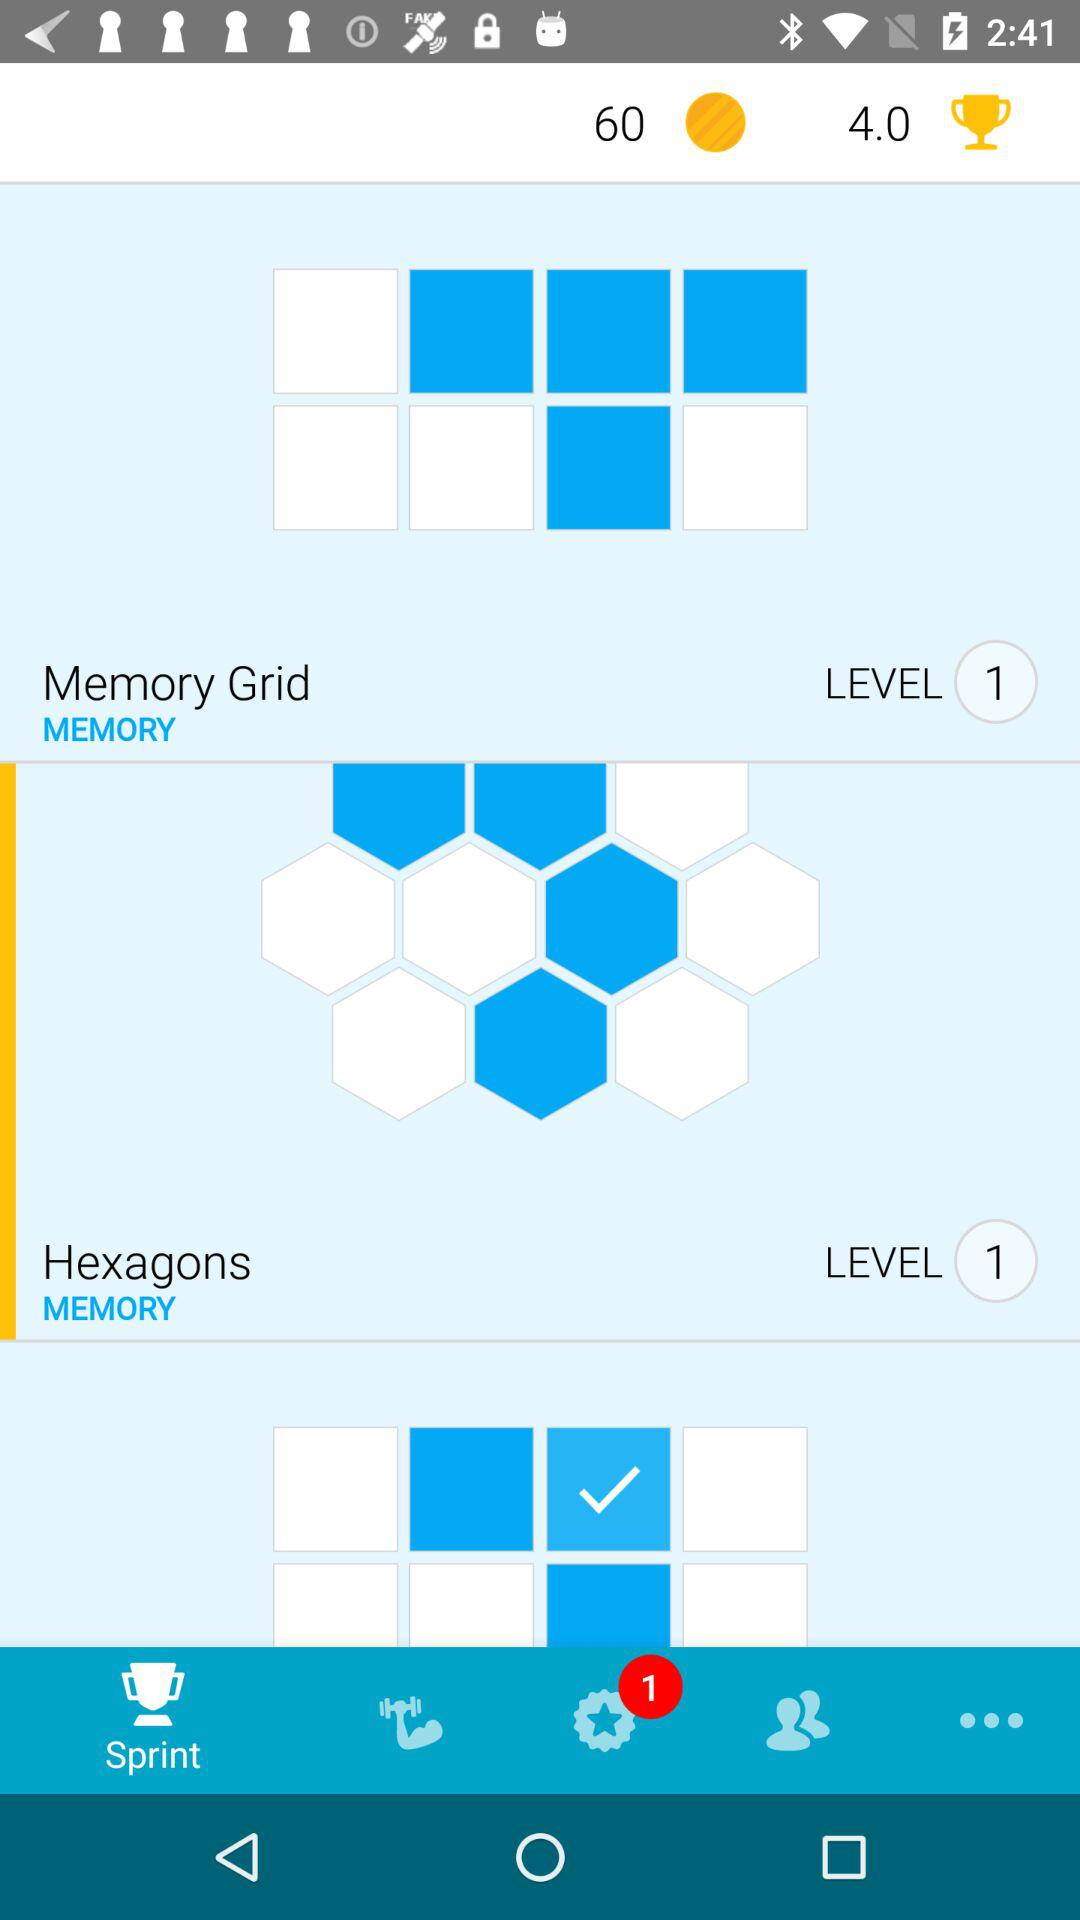What is the level of the Memory Grid?
Answer the question using a single word or phrase. 1 